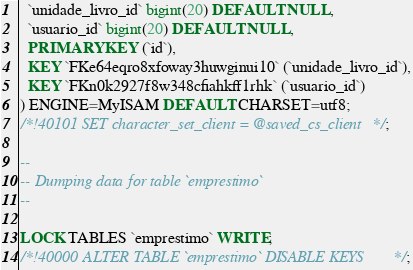Convert code to text. <code><loc_0><loc_0><loc_500><loc_500><_SQL_>  `unidade_livro_id` bigint(20) DEFAULT NULL,
  `usuario_id` bigint(20) DEFAULT NULL,
  PRIMARY KEY (`id`),
  KEY `FKe64eqro8xfoway3huwginui10` (`unidade_livro_id`),
  KEY `FKn0k2927f8w348cfiahkff1rhk` (`usuario_id`)
) ENGINE=MyISAM DEFAULT CHARSET=utf8;
/*!40101 SET character_set_client = @saved_cs_client */;

--
-- Dumping data for table `emprestimo`
--

LOCK TABLES `emprestimo` WRITE;
/*!40000 ALTER TABLE `emprestimo` DISABLE KEYS */;</code> 